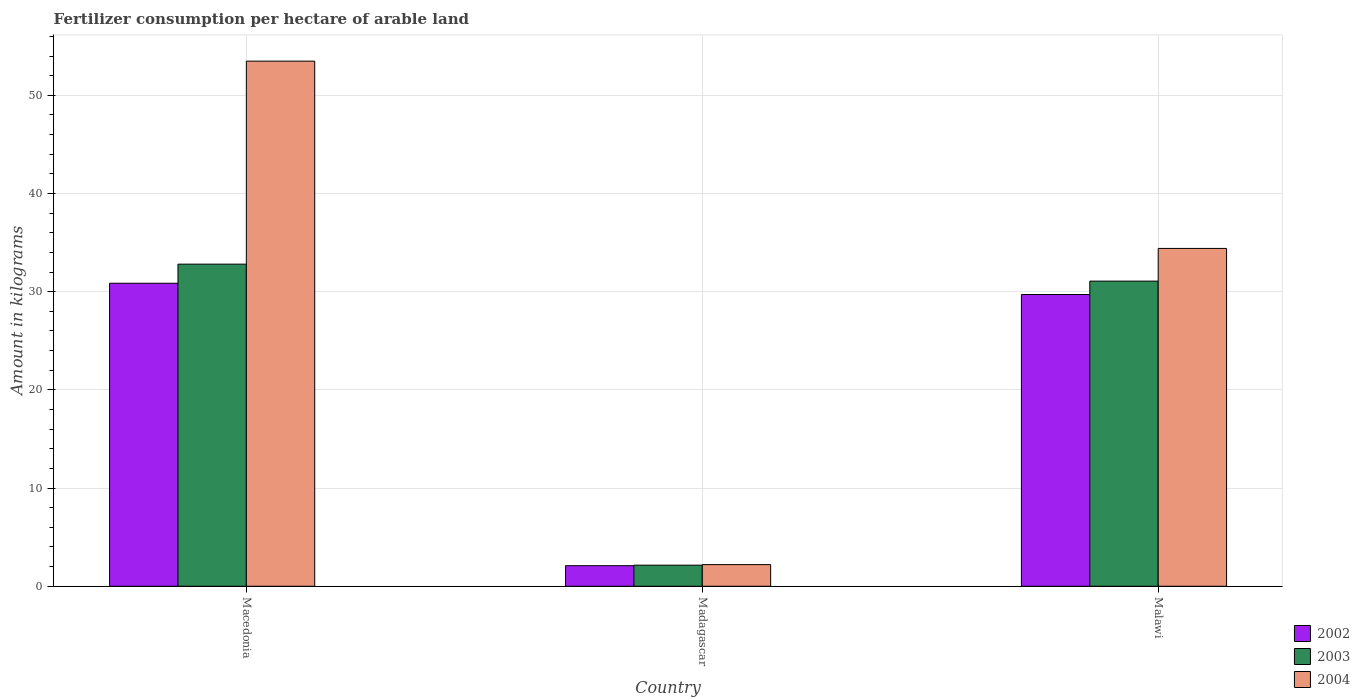How many different coloured bars are there?
Provide a short and direct response. 3. Are the number of bars per tick equal to the number of legend labels?
Give a very brief answer. Yes. How many bars are there on the 1st tick from the right?
Offer a very short reply. 3. What is the label of the 1st group of bars from the left?
Your response must be concise. Macedonia. What is the amount of fertilizer consumption in 2002 in Malawi?
Your response must be concise. 29.71. Across all countries, what is the maximum amount of fertilizer consumption in 2004?
Provide a succinct answer. 53.48. Across all countries, what is the minimum amount of fertilizer consumption in 2002?
Provide a short and direct response. 2.09. In which country was the amount of fertilizer consumption in 2004 maximum?
Provide a succinct answer. Macedonia. In which country was the amount of fertilizer consumption in 2004 minimum?
Give a very brief answer. Madagascar. What is the total amount of fertilizer consumption in 2002 in the graph?
Your answer should be very brief. 62.67. What is the difference between the amount of fertilizer consumption in 2002 in Madagascar and that in Malawi?
Offer a terse response. -27.62. What is the difference between the amount of fertilizer consumption in 2003 in Macedonia and the amount of fertilizer consumption in 2002 in Malawi?
Make the answer very short. 3.09. What is the average amount of fertilizer consumption in 2003 per country?
Your answer should be compact. 22.01. What is the difference between the amount of fertilizer consumption of/in 2003 and amount of fertilizer consumption of/in 2002 in Madagascar?
Give a very brief answer. 0.05. In how many countries, is the amount of fertilizer consumption in 2003 greater than 54 kg?
Keep it short and to the point. 0. What is the ratio of the amount of fertilizer consumption in 2002 in Madagascar to that in Malawi?
Provide a succinct answer. 0.07. Is the difference between the amount of fertilizer consumption in 2003 in Macedonia and Malawi greater than the difference between the amount of fertilizer consumption in 2002 in Macedonia and Malawi?
Offer a very short reply. Yes. What is the difference between the highest and the second highest amount of fertilizer consumption in 2004?
Your answer should be very brief. 32.2. What is the difference between the highest and the lowest amount of fertilizer consumption in 2003?
Provide a short and direct response. 30.66. In how many countries, is the amount of fertilizer consumption in 2002 greater than the average amount of fertilizer consumption in 2002 taken over all countries?
Offer a terse response. 2. Is the sum of the amount of fertilizer consumption in 2003 in Macedonia and Madagascar greater than the maximum amount of fertilizer consumption in 2004 across all countries?
Keep it short and to the point. No. Is it the case that in every country, the sum of the amount of fertilizer consumption in 2004 and amount of fertilizer consumption in 2002 is greater than the amount of fertilizer consumption in 2003?
Provide a short and direct response. Yes. Are all the bars in the graph horizontal?
Provide a succinct answer. No. How many countries are there in the graph?
Give a very brief answer. 3. Are the values on the major ticks of Y-axis written in scientific E-notation?
Offer a terse response. No. Does the graph contain grids?
Offer a very short reply. Yes. Where does the legend appear in the graph?
Give a very brief answer. Bottom right. How many legend labels are there?
Give a very brief answer. 3. What is the title of the graph?
Provide a short and direct response. Fertilizer consumption per hectare of arable land. What is the label or title of the X-axis?
Your response must be concise. Country. What is the label or title of the Y-axis?
Provide a short and direct response. Amount in kilograms. What is the Amount in kilograms in 2002 in Macedonia?
Make the answer very short. 30.86. What is the Amount in kilograms in 2003 in Macedonia?
Ensure brevity in your answer.  32.8. What is the Amount in kilograms of 2004 in Macedonia?
Make the answer very short. 53.48. What is the Amount in kilograms in 2002 in Madagascar?
Your response must be concise. 2.09. What is the Amount in kilograms in 2003 in Madagascar?
Make the answer very short. 2.15. What is the Amount in kilograms in 2004 in Madagascar?
Provide a succinct answer. 2.2. What is the Amount in kilograms in 2002 in Malawi?
Your answer should be compact. 29.71. What is the Amount in kilograms in 2003 in Malawi?
Your answer should be very brief. 31.08. What is the Amount in kilograms of 2004 in Malawi?
Ensure brevity in your answer.  34.41. Across all countries, what is the maximum Amount in kilograms of 2002?
Provide a succinct answer. 30.86. Across all countries, what is the maximum Amount in kilograms of 2003?
Keep it short and to the point. 32.8. Across all countries, what is the maximum Amount in kilograms in 2004?
Your answer should be very brief. 53.48. Across all countries, what is the minimum Amount in kilograms of 2002?
Your answer should be very brief. 2.09. Across all countries, what is the minimum Amount in kilograms of 2003?
Keep it short and to the point. 2.15. Across all countries, what is the minimum Amount in kilograms in 2004?
Provide a succinct answer. 2.2. What is the total Amount in kilograms in 2002 in the graph?
Your answer should be compact. 62.67. What is the total Amount in kilograms of 2003 in the graph?
Your answer should be compact. 66.03. What is the total Amount in kilograms of 2004 in the graph?
Provide a short and direct response. 90.09. What is the difference between the Amount in kilograms of 2002 in Macedonia and that in Madagascar?
Offer a very short reply. 28.77. What is the difference between the Amount in kilograms in 2003 in Macedonia and that in Madagascar?
Offer a very short reply. 30.66. What is the difference between the Amount in kilograms in 2004 in Macedonia and that in Madagascar?
Provide a succinct answer. 51.28. What is the difference between the Amount in kilograms of 2002 in Macedonia and that in Malawi?
Provide a succinct answer. 1.15. What is the difference between the Amount in kilograms in 2003 in Macedonia and that in Malawi?
Provide a short and direct response. 1.73. What is the difference between the Amount in kilograms in 2004 in Macedonia and that in Malawi?
Keep it short and to the point. 19.08. What is the difference between the Amount in kilograms of 2002 in Madagascar and that in Malawi?
Give a very brief answer. -27.62. What is the difference between the Amount in kilograms of 2003 in Madagascar and that in Malawi?
Give a very brief answer. -28.93. What is the difference between the Amount in kilograms of 2004 in Madagascar and that in Malawi?
Make the answer very short. -32.2. What is the difference between the Amount in kilograms of 2002 in Macedonia and the Amount in kilograms of 2003 in Madagascar?
Offer a very short reply. 28.71. What is the difference between the Amount in kilograms in 2002 in Macedonia and the Amount in kilograms in 2004 in Madagascar?
Ensure brevity in your answer.  28.66. What is the difference between the Amount in kilograms of 2003 in Macedonia and the Amount in kilograms of 2004 in Madagascar?
Provide a short and direct response. 30.6. What is the difference between the Amount in kilograms in 2002 in Macedonia and the Amount in kilograms in 2003 in Malawi?
Offer a very short reply. -0.22. What is the difference between the Amount in kilograms of 2002 in Macedonia and the Amount in kilograms of 2004 in Malawi?
Give a very brief answer. -3.55. What is the difference between the Amount in kilograms in 2003 in Macedonia and the Amount in kilograms in 2004 in Malawi?
Ensure brevity in your answer.  -1.6. What is the difference between the Amount in kilograms in 2002 in Madagascar and the Amount in kilograms in 2003 in Malawi?
Your answer should be compact. -28.98. What is the difference between the Amount in kilograms in 2002 in Madagascar and the Amount in kilograms in 2004 in Malawi?
Your response must be concise. -32.31. What is the difference between the Amount in kilograms of 2003 in Madagascar and the Amount in kilograms of 2004 in Malawi?
Provide a succinct answer. -32.26. What is the average Amount in kilograms in 2002 per country?
Offer a terse response. 20.89. What is the average Amount in kilograms of 2003 per country?
Your answer should be very brief. 22.01. What is the average Amount in kilograms in 2004 per country?
Ensure brevity in your answer.  30.03. What is the difference between the Amount in kilograms of 2002 and Amount in kilograms of 2003 in Macedonia?
Keep it short and to the point. -1.95. What is the difference between the Amount in kilograms of 2002 and Amount in kilograms of 2004 in Macedonia?
Make the answer very short. -22.62. What is the difference between the Amount in kilograms in 2003 and Amount in kilograms in 2004 in Macedonia?
Offer a terse response. -20.68. What is the difference between the Amount in kilograms in 2002 and Amount in kilograms in 2003 in Madagascar?
Provide a short and direct response. -0.05. What is the difference between the Amount in kilograms in 2002 and Amount in kilograms in 2004 in Madagascar?
Your answer should be compact. -0.11. What is the difference between the Amount in kilograms in 2003 and Amount in kilograms in 2004 in Madagascar?
Your answer should be very brief. -0.05. What is the difference between the Amount in kilograms of 2002 and Amount in kilograms of 2003 in Malawi?
Your answer should be compact. -1.36. What is the difference between the Amount in kilograms in 2002 and Amount in kilograms in 2004 in Malawi?
Your response must be concise. -4.69. What is the difference between the Amount in kilograms of 2003 and Amount in kilograms of 2004 in Malawi?
Give a very brief answer. -3.33. What is the ratio of the Amount in kilograms of 2002 in Macedonia to that in Madagascar?
Ensure brevity in your answer.  14.74. What is the ratio of the Amount in kilograms in 2003 in Macedonia to that in Madagascar?
Give a very brief answer. 15.27. What is the ratio of the Amount in kilograms in 2004 in Macedonia to that in Madagascar?
Offer a very short reply. 24.28. What is the ratio of the Amount in kilograms in 2002 in Macedonia to that in Malawi?
Offer a very short reply. 1.04. What is the ratio of the Amount in kilograms in 2003 in Macedonia to that in Malawi?
Your answer should be compact. 1.06. What is the ratio of the Amount in kilograms in 2004 in Macedonia to that in Malawi?
Provide a succinct answer. 1.55. What is the ratio of the Amount in kilograms in 2002 in Madagascar to that in Malawi?
Keep it short and to the point. 0.07. What is the ratio of the Amount in kilograms in 2003 in Madagascar to that in Malawi?
Your response must be concise. 0.07. What is the ratio of the Amount in kilograms in 2004 in Madagascar to that in Malawi?
Give a very brief answer. 0.06. What is the difference between the highest and the second highest Amount in kilograms in 2002?
Give a very brief answer. 1.15. What is the difference between the highest and the second highest Amount in kilograms in 2003?
Offer a terse response. 1.73. What is the difference between the highest and the second highest Amount in kilograms of 2004?
Give a very brief answer. 19.08. What is the difference between the highest and the lowest Amount in kilograms in 2002?
Your answer should be very brief. 28.77. What is the difference between the highest and the lowest Amount in kilograms in 2003?
Offer a very short reply. 30.66. What is the difference between the highest and the lowest Amount in kilograms in 2004?
Your answer should be compact. 51.28. 